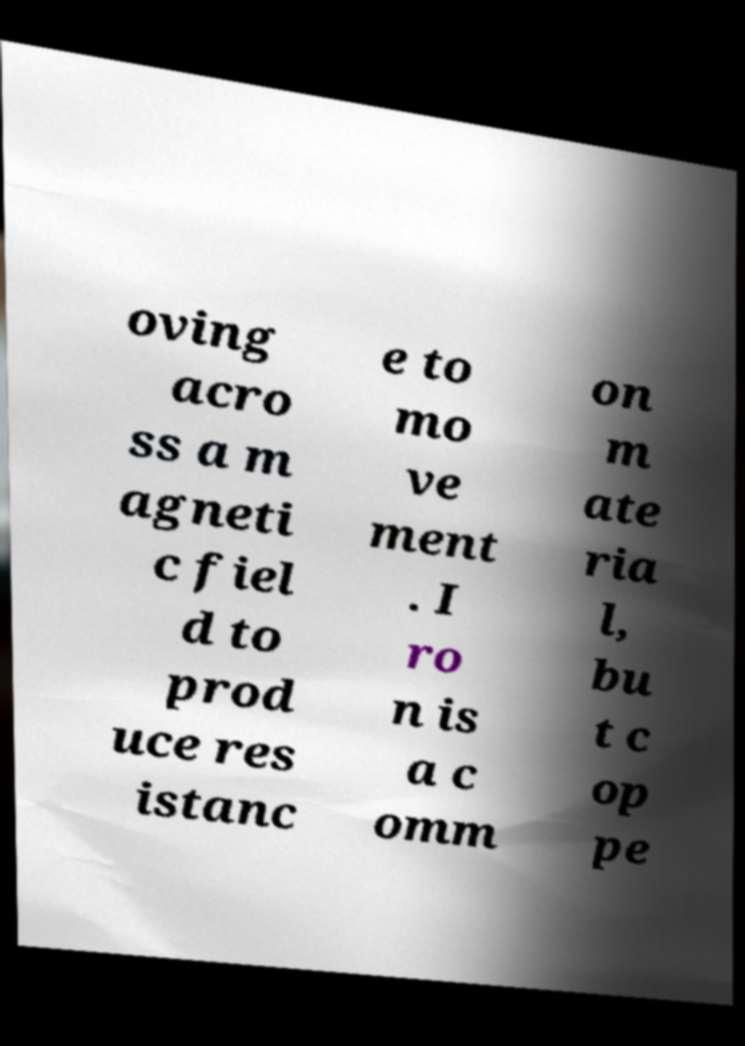Can you accurately transcribe the text from the provided image for me? oving acro ss a m agneti c fiel d to prod uce res istanc e to mo ve ment . I ro n is a c omm on m ate ria l, bu t c op pe 